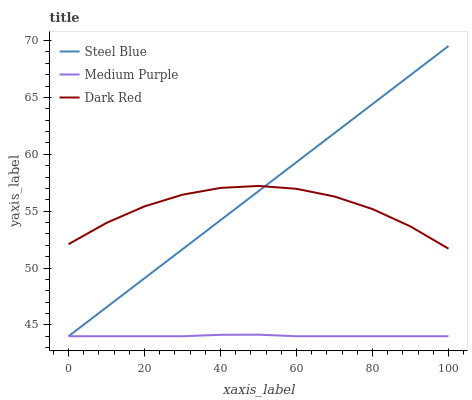Does Medium Purple have the minimum area under the curve?
Answer yes or no. Yes. Does Steel Blue have the maximum area under the curve?
Answer yes or no. Yes. Does Dark Red have the minimum area under the curve?
Answer yes or no. No. Does Dark Red have the maximum area under the curve?
Answer yes or no. No. Is Steel Blue the smoothest?
Answer yes or no. Yes. Is Dark Red the roughest?
Answer yes or no. Yes. Is Dark Red the smoothest?
Answer yes or no. No. Is Steel Blue the roughest?
Answer yes or no. No. Does Medium Purple have the lowest value?
Answer yes or no. Yes. Does Dark Red have the lowest value?
Answer yes or no. No. Does Steel Blue have the highest value?
Answer yes or no. Yes. Does Dark Red have the highest value?
Answer yes or no. No. Is Medium Purple less than Dark Red?
Answer yes or no. Yes. Is Dark Red greater than Medium Purple?
Answer yes or no. Yes. Does Steel Blue intersect Dark Red?
Answer yes or no. Yes. Is Steel Blue less than Dark Red?
Answer yes or no. No. Is Steel Blue greater than Dark Red?
Answer yes or no. No. Does Medium Purple intersect Dark Red?
Answer yes or no. No. 